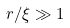<formula> <loc_0><loc_0><loc_500><loc_500>r / \xi \gg 1</formula> 